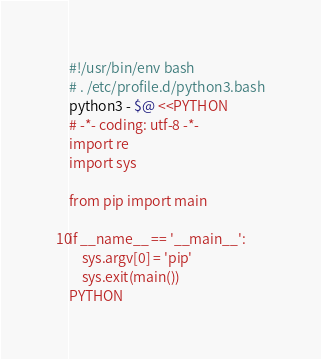Convert code to text. <code><loc_0><loc_0><loc_500><loc_500><_Bash_>#!/usr/bin/env bash
# . /etc/profile.d/python3.bash
python3 - $@ <<PYTHON
# -*- coding: utf-8 -*-
import re
import sys

from pip import main

if __name__ == '__main__':
    sys.argv[0] = 'pip'
    sys.exit(main())
PYTHON
</code> 